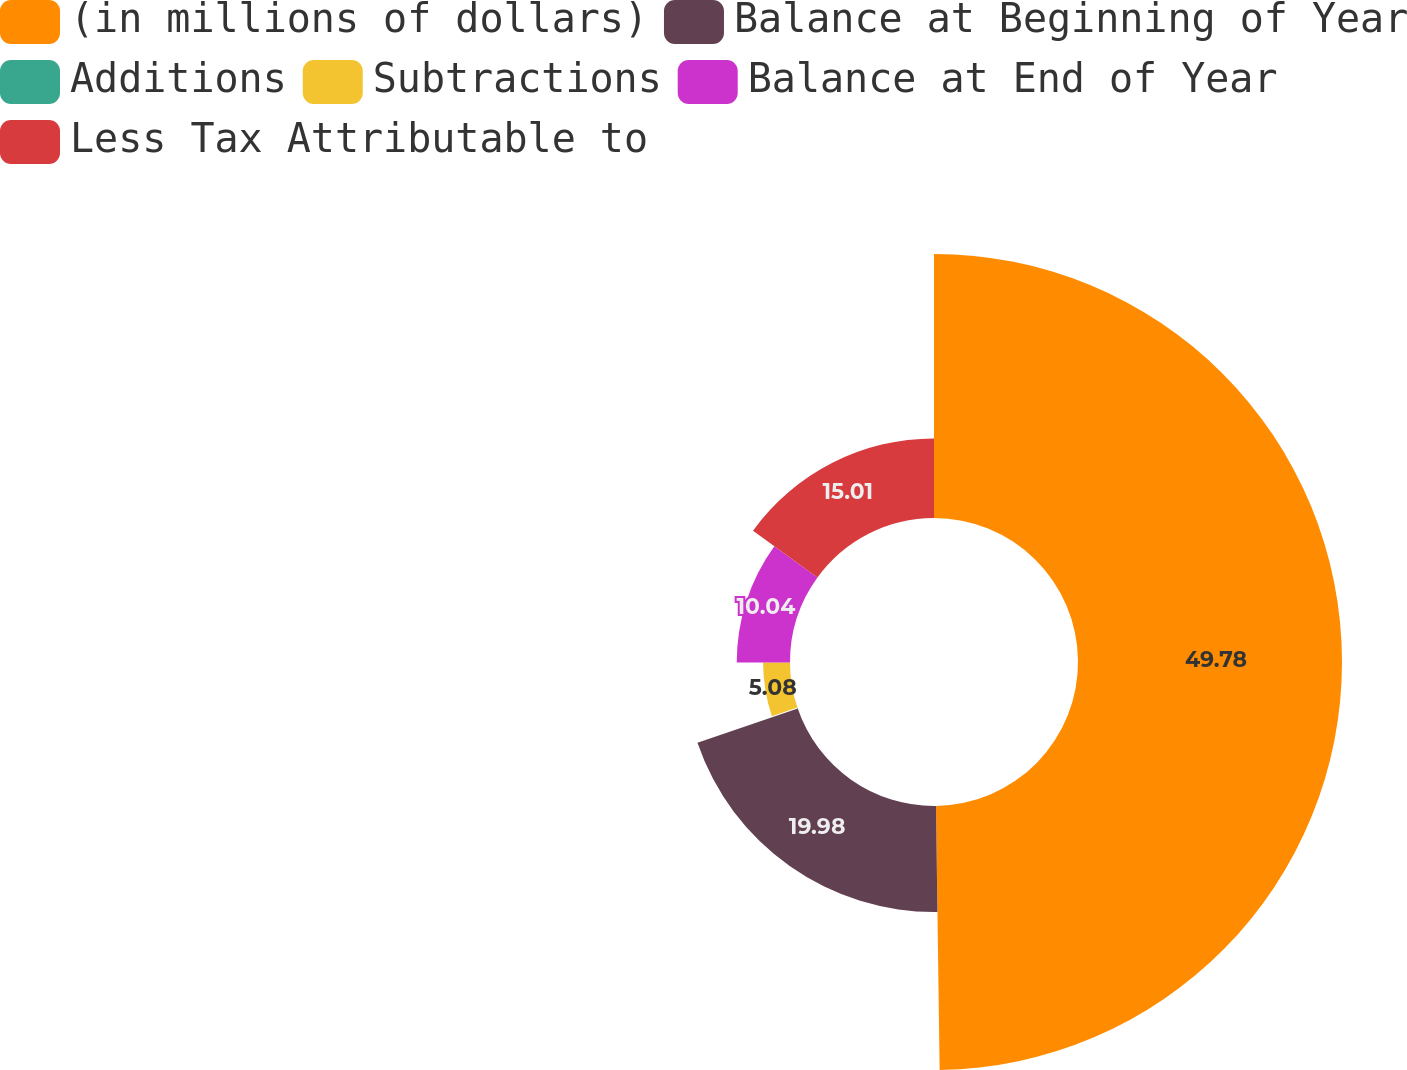Convert chart. <chart><loc_0><loc_0><loc_500><loc_500><pie_chart><fcel>(in millions of dollars)<fcel>Balance at Beginning of Year<fcel>Additions<fcel>Subtractions<fcel>Balance at End of Year<fcel>Less Tax Attributable to<nl><fcel>49.78%<fcel>19.98%<fcel>0.11%<fcel>5.08%<fcel>10.04%<fcel>15.01%<nl></chart> 